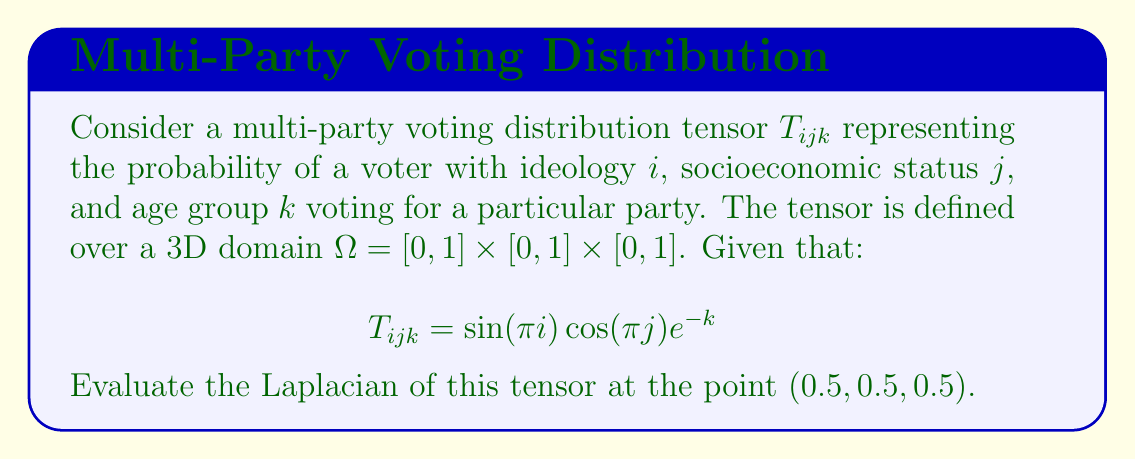Teach me how to tackle this problem. To solve this problem, we'll follow these steps:

1) The Laplacian of a tensor $T_{ijk}$ in 3D is defined as:

   $$\nabla^2 T_{ijk} = \frac{\partial^2 T_{ijk}}{\partial i^2} + \frac{\partial^2 T_{ijk}}{\partial j^2} + \frac{\partial^2 T_{ijk}}{\partial k^2}$$

2) Let's calculate each second partial derivative:

   a) $\frac{\partial^2 T_{ijk}}{\partial i^2}$:
      $\frac{\partial T_{ijk}}{\partial i} = \pi \cos(\pi i) \cos(\pi j) e^{-k}$
      $\frac{\partial^2 T_{ijk}}{\partial i^2} = -\pi^2 \sin(\pi i) \cos(\pi j) e^{-k}$

   b) $\frac{\partial^2 T_{ijk}}{\partial j^2}$:
      $\frac{\partial T_{ijk}}{\partial j} = -\pi \sin(\pi i) \sin(\pi j) e^{-k}$
      $\frac{\partial^2 T_{ijk}}{\partial j^2} = -\pi^2 \sin(\pi i) \cos(\pi j) e^{-k}$

   c) $\frac{\partial^2 T_{ijk}}{\partial k^2}$:
      $\frac{\partial T_{ijk}}{\partial k} = -\sin(\pi i) \cos(\pi j) e^{-k}$
      $\frac{\partial^2 T_{ijk}}{\partial k^2} = \sin(\pi i) \cos(\pi j) e^{-k}$

3) Now, we sum these second partial derivatives:

   $$\nabla^2 T_{ijk} = (-\pi^2 - \pi^2 + 1) \sin(\pi i) \cos(\pi j) e^{-k}$$

4) Evaluate at the point (0.5, 0.5, 0.5):

   $$\nabla^2 T_{0.5,0.5,0.5} = (-2\pi^2 + 1) \sin(\pi/2) \cos(\pi/2) e^{-0.5}$$

5) Simplify:
   $\sin(\pi/2) = 1$, $\cos(\pi/2) = 0$

   $$\nabla^2 T_{0.5,0.5,0.5} = 0$$
Answer: $0$ 